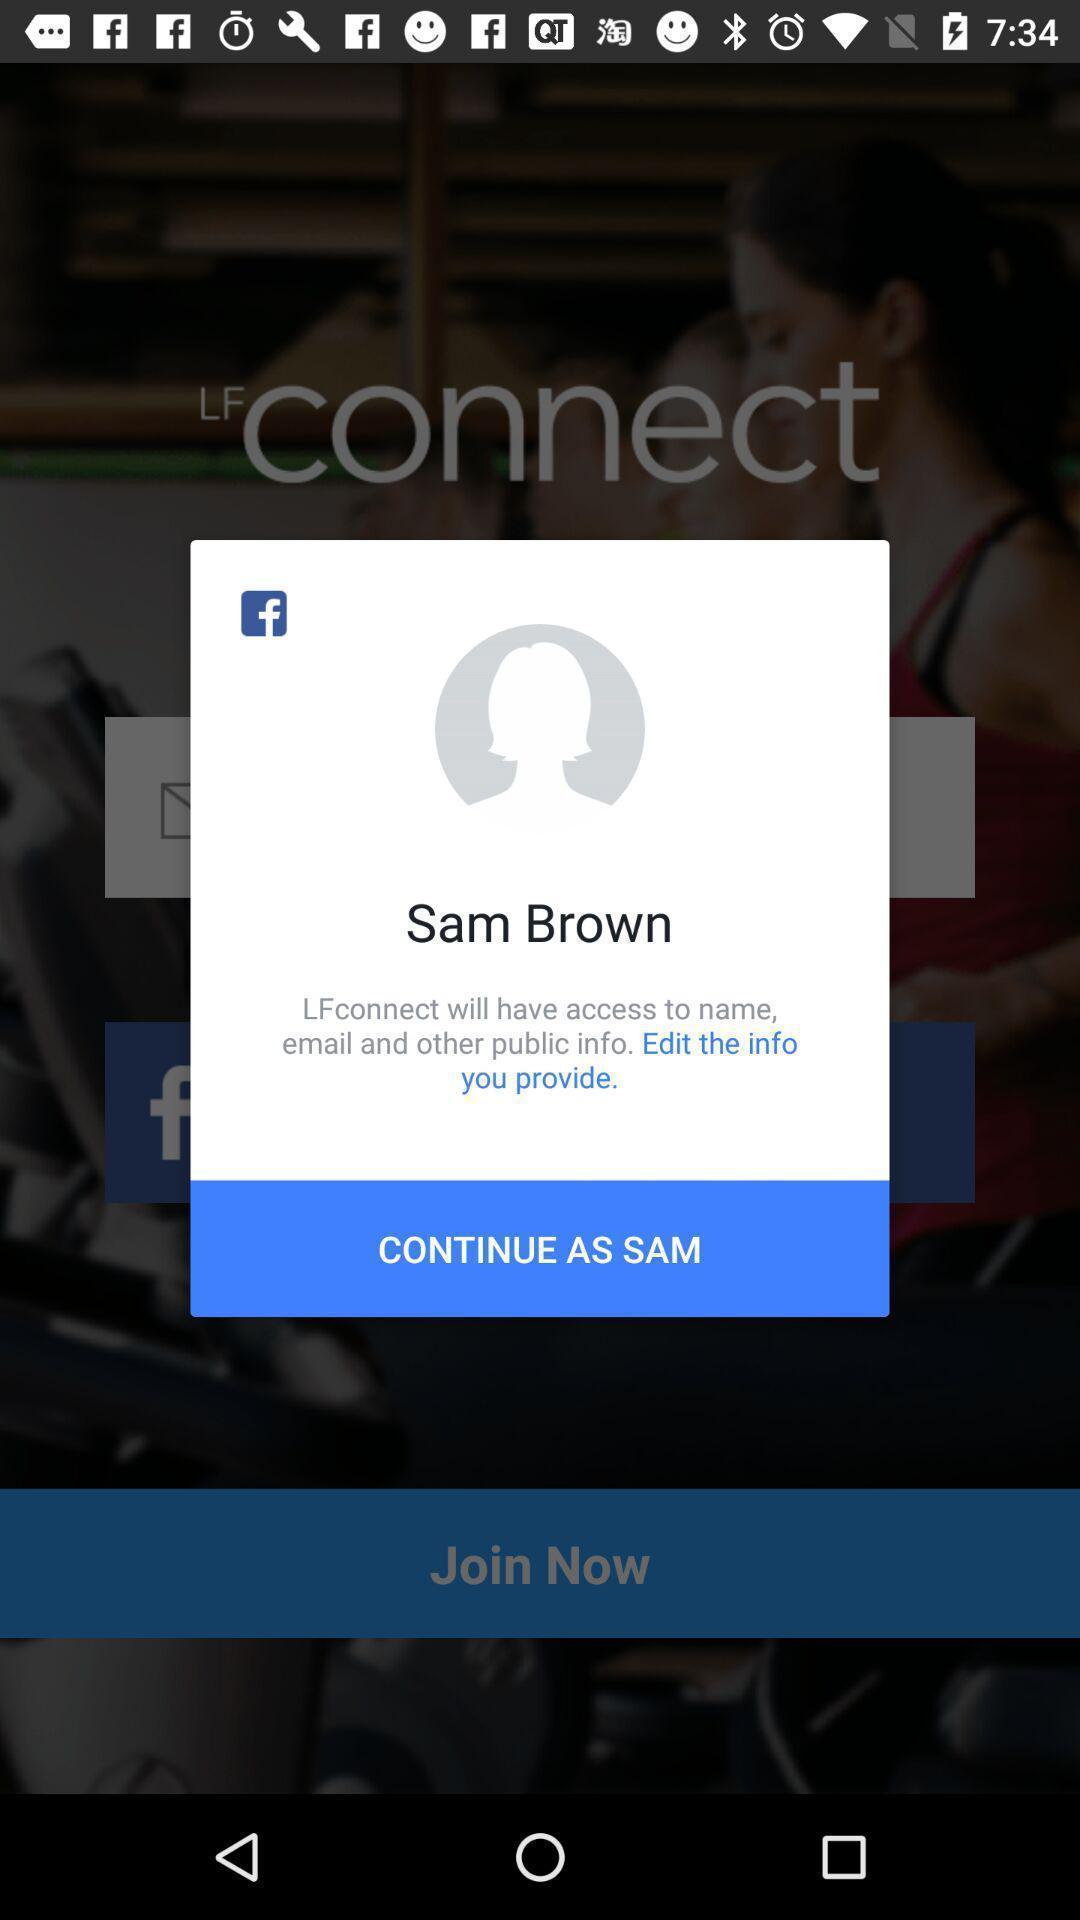Describe the content in this image. Popup to continue in the health fitness app. 